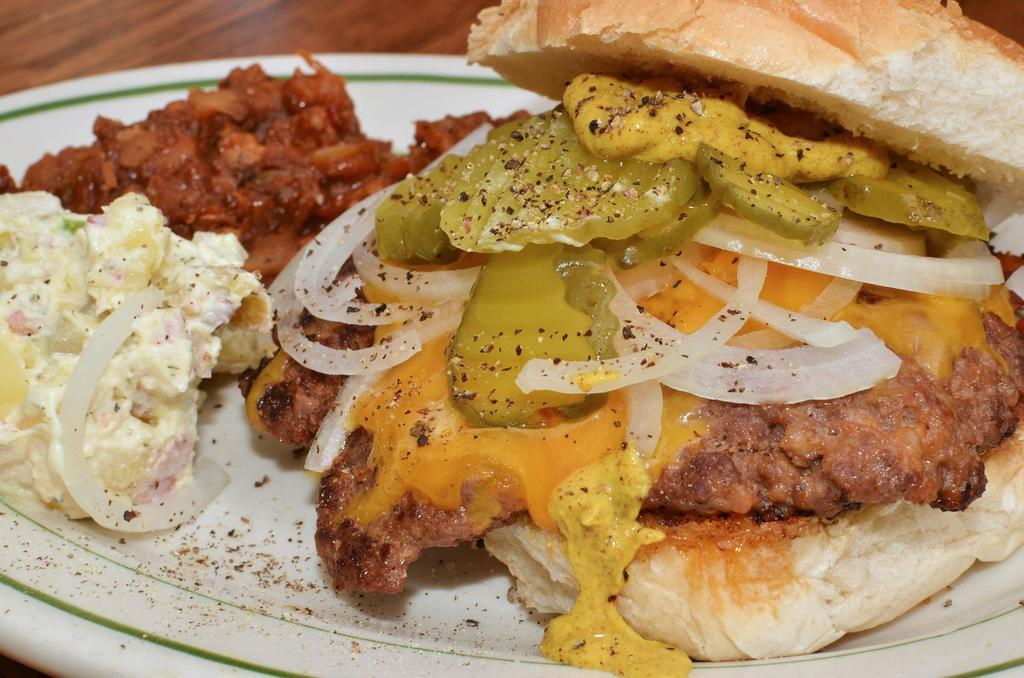What is placed in a plate in the image? There is food placed in a plate in the image. Where is the plate located in the image? The plate is on a surface in the image. What type of cup can be seen holding songs in the image? There is no cup or songs present in the image. 